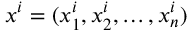Convert formula to latex. <formula><loc_0><loc_0><loc_500><loc_500>x ^ { i } = ( x _ { 1 } ^ { i } , x _ { 2 } ^ { i } , \dots , x _ { n } ^ { i } )</formula> 